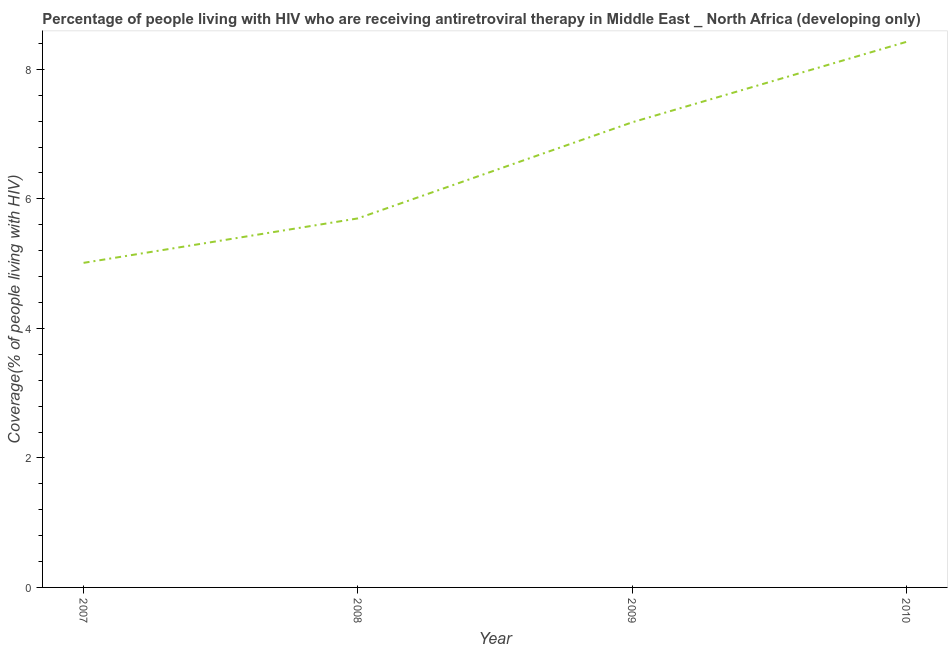What is the antiretroviral therapy coverage in 2009?
Keep it short and to the point. 7.18. Across all years, what is the maximum antiretroviral therapy coverage?
Your answer should be compact. 8.42. Across all years, what is the minimum antiretroviral therapy coverage?
Your answer should be very brief. 5.01. In which year was the antiretroviral therapy coverage minimum?
Your answer should be very brief. 2007. What is the sum of the antiretroviral therapy coverage?
Offer a very short reply. 26.32. What is the difference between the antiretroviral therapy coverage in 2008 and 2009?
Keep it short and to the point. -1.48. What is the average antiretroviral therapy coverage per year?
Your response must be concise. 6.58. What is the median antiretroviral therapy coverage?
Give a very brief answer. 6.44. In how many years, is the antiretroviral therapy coverage greater than 2.8 %?
Make the answer very short. 4. What is the ratio of the antiretroviral therapy coverage in 2007 to that in 2009?
Provide a short and direct response. 0.7. Is the antiretroviral therapy coverage in 2007 less than that in 2010?
Offer a very short reply. Yes. Is the difference between the antiretroviral therapy coverage in 2008 and 2010 greater than the difference between any two years?
Ensure brevity in your answer.  No. What is the difference between the highest and the second highest antiretroviral therapy coverage?
Your answer should be very brief. 1.24. Is the sum of the antiretroviral therapy coverage in 2007 and 2010 greater than the maximum antiretroviral therapy coverage across all years?
Ensure brevity in your answer.  Yes. What is the difference between the highest and the lowest antiretroviral therapy coverage?
Provide a succinct answer. 3.41. Does the antiretroviral therapy coverage monotonically increase over the years?
Offer a terse response. Yes. How many lines are there?
Your answer should be very brief. 1. Are the values on the major ticks of Y-axis written in scientific E-notation?
Provide a short and direct response. No. Does the graph contain any zero values?
Offer a very short reply. No. Does the graph contain grids?
Your response must be concise. No. What is the title of the graph?
Your response must be concise. Percentage of people living with HIV who are receiving antiretroviral therapy in Middle East _ North Africa (developing only). What is the label or title of the X-axis?
Give a very brief answer. Year. What is the label or title of the Y-axis?
Ensure brevity in your answer.  Coverage(% of people living with HIV). What is the Coverage(% of people living with HIV) in 2007?
Offer a terse response. 5.01. What is the Coverage(% of people living with HIV) in 2008?
Provide a short and direct response. 5.7. What is the Coverage(% of people living with HIV) in 2009?
Provide a succinct answer. 7.18. What is the Coverage(% of people living with HIV) in 2010?
Provide a succinct answer. 8.42. What is the difference between the Coverage(% of people living with HIV) in 2007 and 2008?
Your answer should be very brief. -0.69. What is the difference between the Coverage(% of people living with HIV) in 2007 and 2009?
Make the answer very short. -2.17. What is the difference between the Coverage(% of people living with HIV) in 2007 and 2010?
Make the answer very short. -3.41. What is the difference between the Coverage(% of people living with HIV) in 2008 and 2009?
Offer a terse response. -1.48. What is the difference between the Coverage(% of people living with HIV) in 2008 and 2010?
Your answer should be very brief. -2.73. What is the difference between the Coverage(% of people living with HIV) in 2009 and 2010?
Offer a very short reply. -1.24. What is the ratio of the Coverage(% of people living with HIV) in 2007 to that in 2008?
Your answer should be compact. 0.88. What is the ratio of the Coverage(% of people living with HIV) in 2007 to that in 2009?
Provide a short and direct response. 0.7. What is the ratio of the Coverage(% of people living with HIV) in 2007 to that in 2010?
Ensure brevity in your answer.  0.59. What is the ratio of the Coverage(% of people living with HIV) in 2008 to that in 2009?
Ensure brevity in your answer.  0.79. What is the ratio of the Coverage(% of people living with HIV) in 2008 to that in 2010?
Your answer should be compact. 0.68. What is the ratio of the Coverage(% of people living with HIV) in 2009 to that in 2010?
Offer a terse response. 0.85. 